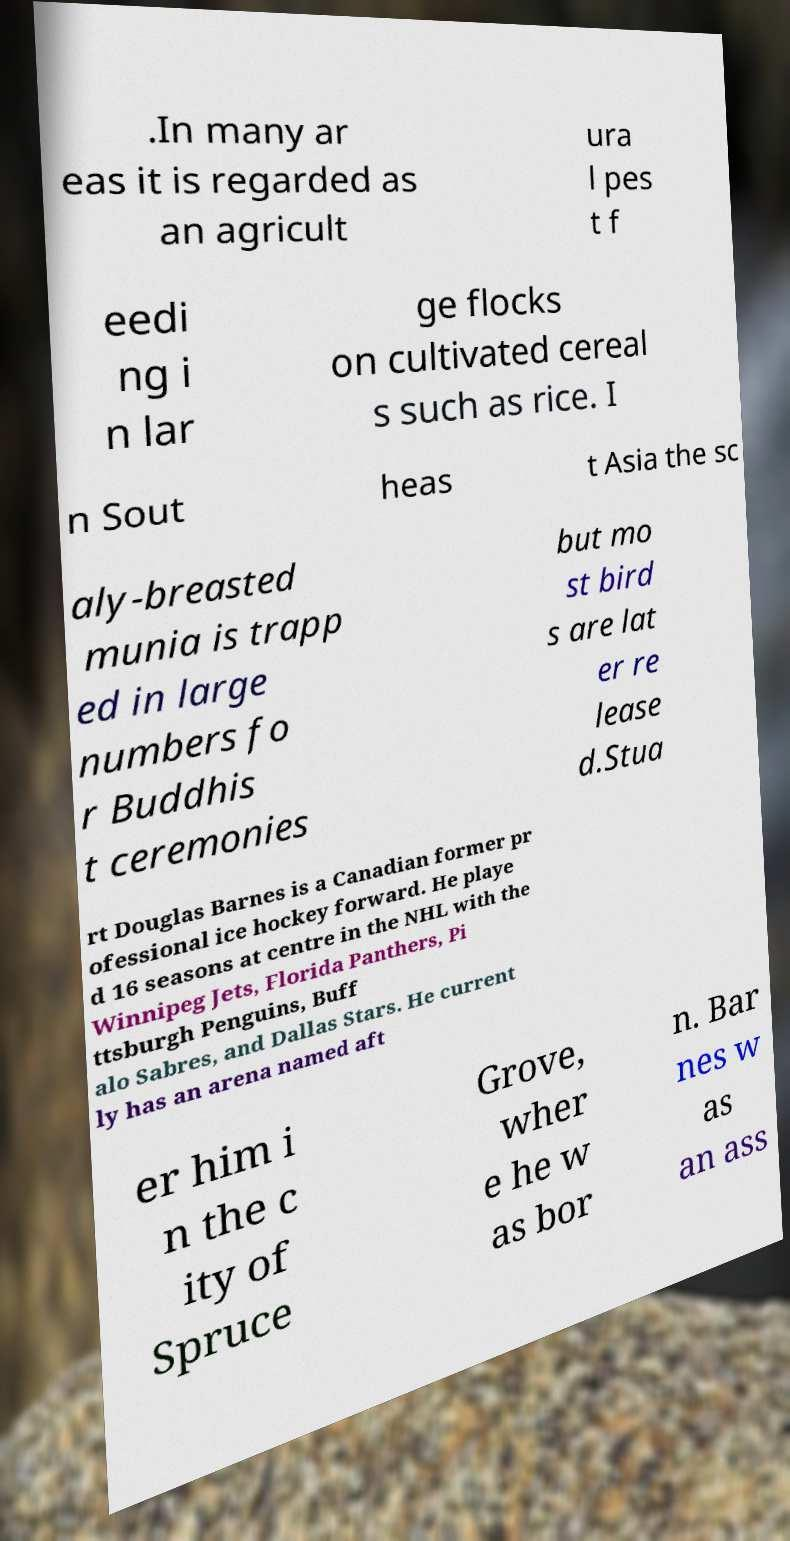Please read and relay the text visible in this image. What does it say? .In many ar eas it is regarded as an agricult ura l pes t f eedi ng i n lar ge flocks on cultivated cereal s such as rice. I n Sout heas t Asia the sc aly-breasted munia is trapp ed in large numbers fo r Buddhis t ceremonies but mo st bird s are lat er re lease d.Stua rt Douglas Barnes is a Canadian former pr ofessional ice hockey forward. He playe d 16 seasons at centre in the NHL with the Winnipeg Jets, Florida Panthers, Pi ttsburgh Penguins, Buff alo Sabres, and Dallas Stars. He current ly has an arena named aft er him i n the c ity of Spruce Grove, wher e he w as bor n. Bar nes w as an ass 